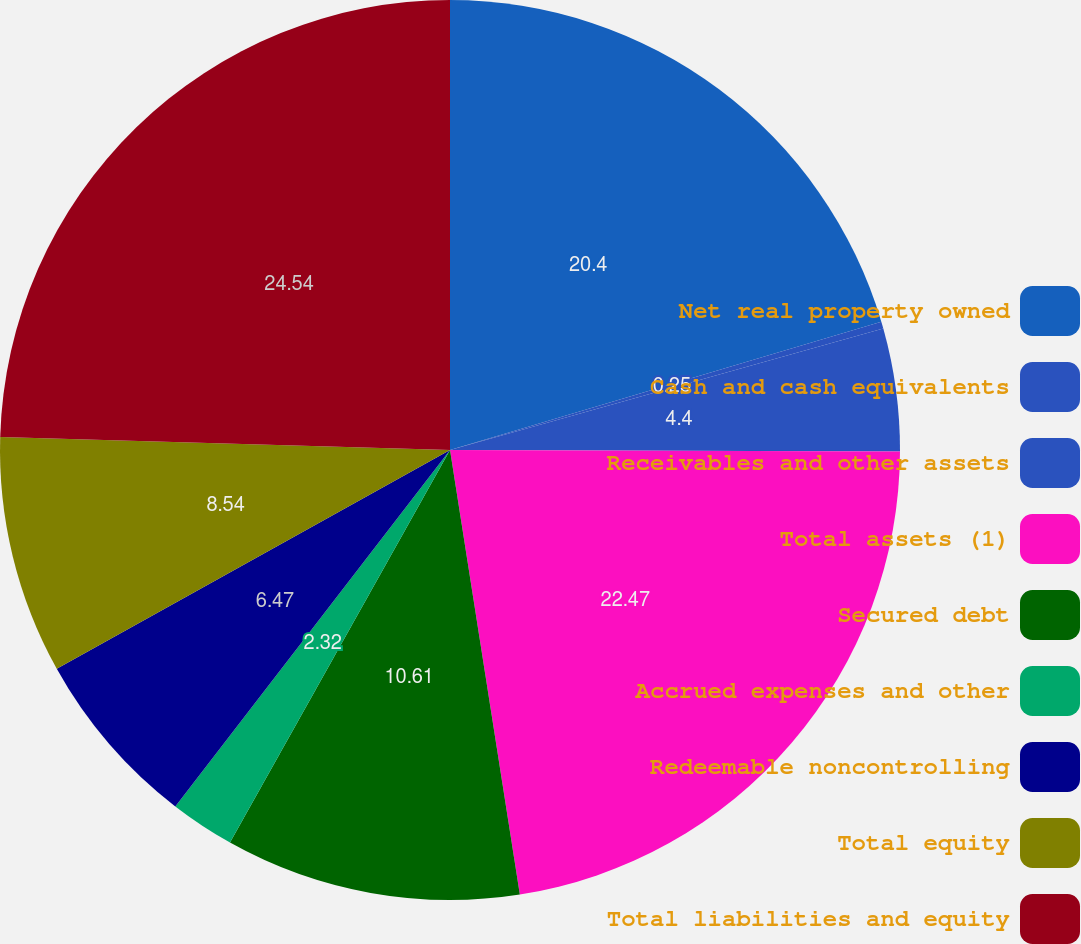<chart> <loc_0><loc_0><loc_500><loc_500><pie_chart><fcel>Net real property owned<fcel>Cash and cash equivalents<fcel>Receivables and other assets<fcel>Total assets (1)<fcel>Secured debt<fcel>Accrued expenses and other<fcel>Redeemable noncontrolling<fcel>Total equity<fcel>Total liabilities and equity<nl><fcel>20.4%<fcel>0.25%<fcel>4.4%<fcel>22.47%<fcel>10.61%<fcel>2.32%<fcel>6.47%<fcel>8.54%<fcel>24.54%<nl></chart> 